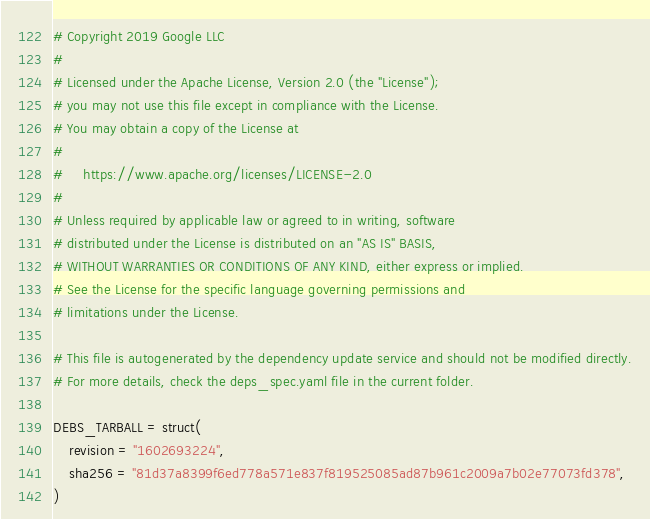Convert code to text. <code><loc_0><loc_0><loc_500><loc_500><_Python_># Copyright 2019 Google LLC
#
# Licensed under the Apache License, Version 2.0 (the "License");
# you may not use this file except in compliance with the License.
# You may obtain a copy of the License at
#
#     https://www.apache.org/licenses/LICENSE-2.0
#
# Unless required by applicable law or agreed to in writing, software
# distributed under the License is distributed on an "AS IS" BASIS,
# WITHOUT WARRANTIES OR CONDITIONS OF ANY KIND, either express or implied.
# See the License for the specific language governing permissions and
# limitations under the License.

# This file is autogenerated by the dependency update service and should not be modified directly.
# For more details, check the deps_spec.yaml file in the current folder.

DEBS_TARBALL = struct(
    revision = "1602693224",
    sha256 = "81d37a8399f6ed778a571e837f819525085ad87b961c2009a7b02e77073fd378",
)
</code> 